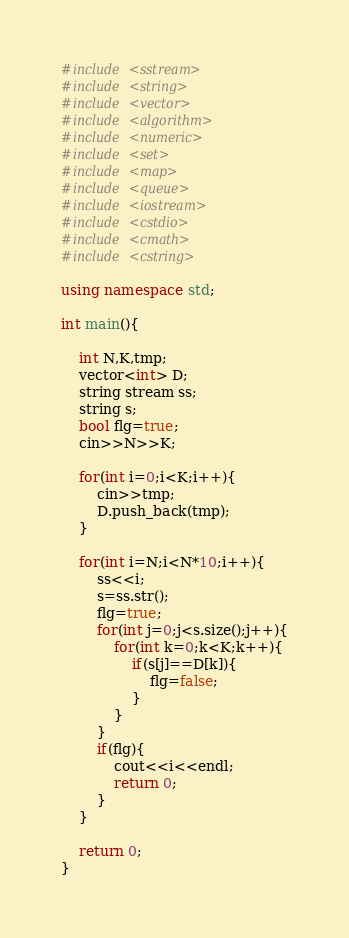Convert code to text. <code><loc_0><loc_0><loc_500><loc_500><_C++_>#include <sstream>
#include <string>
#include <vector>
#include <algorithm>
#include <numeric>
#include <set>
#include <map>
#include <queue>
#include <iostream>
#include <cstdio>
#include <cmath>
#include <cstring>

using namespace std;

int main(){
	
	int N,K,tmp;
	vector<int> D;
	string stream ss;
	string s;
	bool flg=true;
	cin>>N>>K;

	for(int i=0;i<K;i++){
		cin>>tmp;
		D.push_back(tmp);
	}

	for(int i=N;i<N*10;i++){
		ss<<i;
		s=ss.str();
		flg=true;
		for(int j=0;j<s.size();j++){
			for(int k=0;k<K;k++){
				if(s[j]==D[k]){
					flg=false;
				}
			}
		}
		if(flg){
			cout<<i<<endl;
			return 0;
		}
	}
		
	return 0;
}</code> 